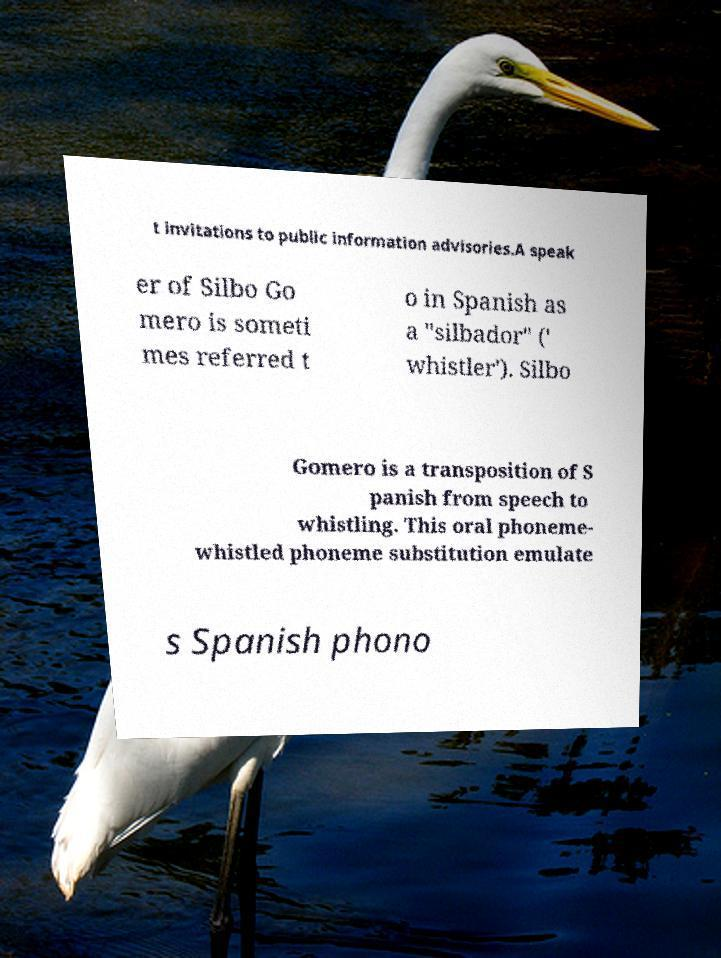There's text embedded in this image that I need extracted. Can you transcribe it verbatim? t invitations to public information advisories.A speak er of Silbo Go mero is someti mes referred t o in Spanish as a "silbador" (' whistler'). Silbo Gomero is a transposition of S panish from speech to whistling. This oral phoneme- whistled phoneme substitution emulate s Spanish phono 